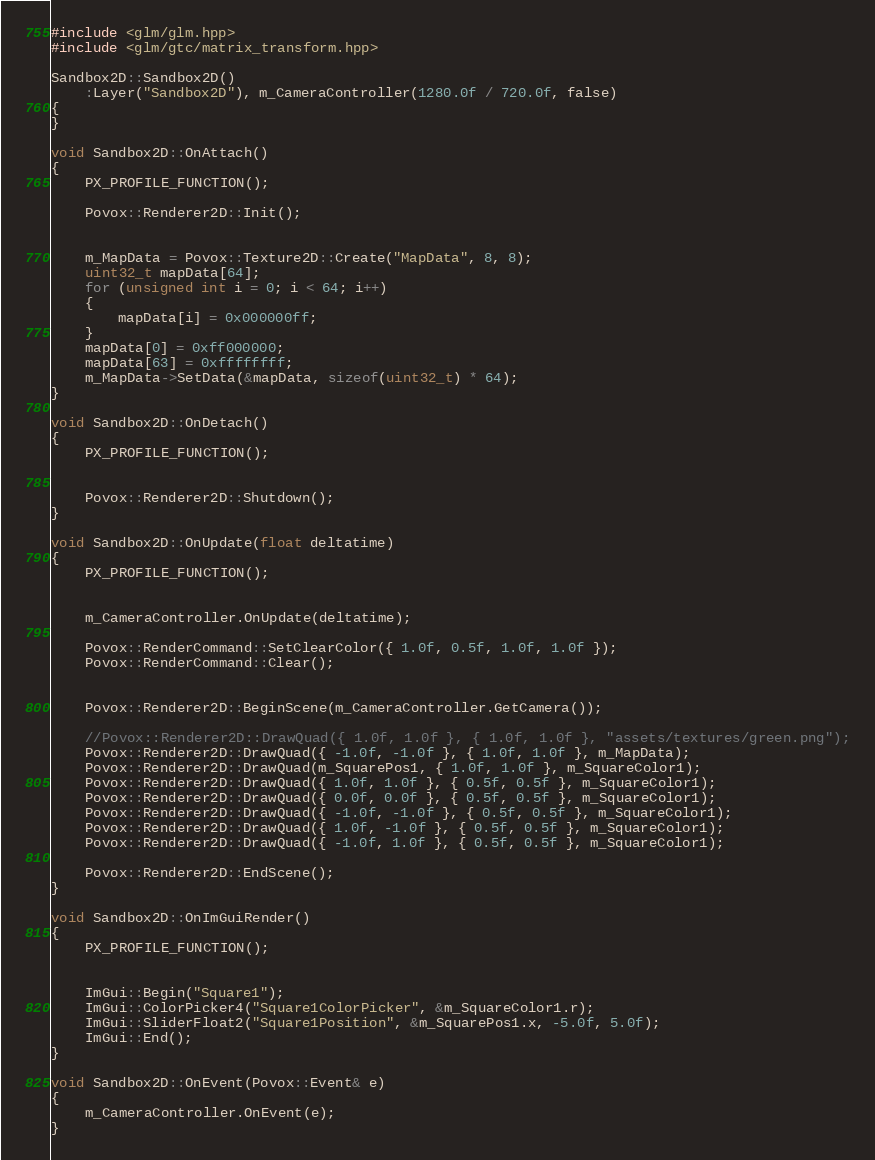Convert code to text. <code><loc_0><loc_0><loc_500><loc_500><_C++_>
#include <glm/glm.hpp>
#include <glm/gtc/matrix_transform.hpp>

Sandbox2D::Sandbox2D()
	:Layer("Sandbox2D"), m_CameraController(1280.0f / 720.0f, false)
{	
}

void Sandbox2D::OnAttach()
{
	PX_PROFILE_FUNCTION();

	Povox::Renderer2D::Init();


	m_MapData = Povox::Texture2D::Create("MapData", 8, 8);
	uint32_t mapData[64];
	for (unsigned int i = 0; i < 64; i++)
	{
		mapData[i] = 0x000000ff;
	}
	mapData[0] = 0xff000000;
	mapData[63] = 0xffffffff;
	m_MapData->SetData(&mapData, sizeof(uint32_t) * 64);
}

void Sandbox2D::OnDetach()
{
	PX_PROFILE_FUNCTION();


	Povox::Renderer2D::Shutdown();
}

void Sandbox2D::OnUpdate(float deltatime)
{
	PX_PROFILE_FUNCTION();


	m_CameraController.OnUpdate(deltatime);

	Povox::RenderCommand::SetClearColor({ 1.0f, 0.5f, 1.0f, 1.0f });
	Povox::RenderCommand::Clear();


	Povox::Renderer2D::BeginScene(m_CameraController.GetCamera());

	//Povox::Renderer2D::DrawQuad({ 1.0f, 1.0f }, { 1.0f, 1.0f }, "assets/textures/green.png");
	Povox::Renderer2D::DrawQuad({ -1.0f, -1.0f }, { 1.0f, 1.0f }, m_MapData);
	Povox::Renderer2D::DrawQuad(m_SquarePos1, { 1.0f, 1.0f }, m_SquareColor1);
	Povox::Renderer2D::DrawQuad({ 1.0f, 1.0f }, { 0.5f, 0.5f }, m_SquareColor1);
	Povox::Renderer2D::DrawQuad({ 0.0f, 0.0f }, { 0.5f, 0.5f }, m_SquareColor1);
	Povox::Renderer2D::DrawQuad({ -1.0f, -1.0f }, { 0.5f, 0.5f }, m_SquareColor1);
	Povox::Renderer2D::DrawQuad({ 1.0f, -1.0f }, { 0.5f, 0.5f }, m_SquareColor1);
	Povox::Renderer2D::DrawQuad({ -1.0f, 1.0f }, { 0.5f, 0.5f }, m_SquareColor1);

	Povox::Renderer2D::EndScene();
}

void Sandbox2D::OnImGuiRender()
{
	PX_PROFILE_FUNCTION();


	ImGui::Begin("Square1");
	ImGui::ColorPicker4("Square1ColorPicker", &m_SquareColor1.r);
	ImGui::SliderFloat2("Square1Position", &m_SquarePos1.x, -5.0f, 5.0f);
	ImGui::End();
}

void Sandbox2D::OnEvent(Povox::Event& e)
{
	m_CameraController.OnEvent(e);
}
</code> 